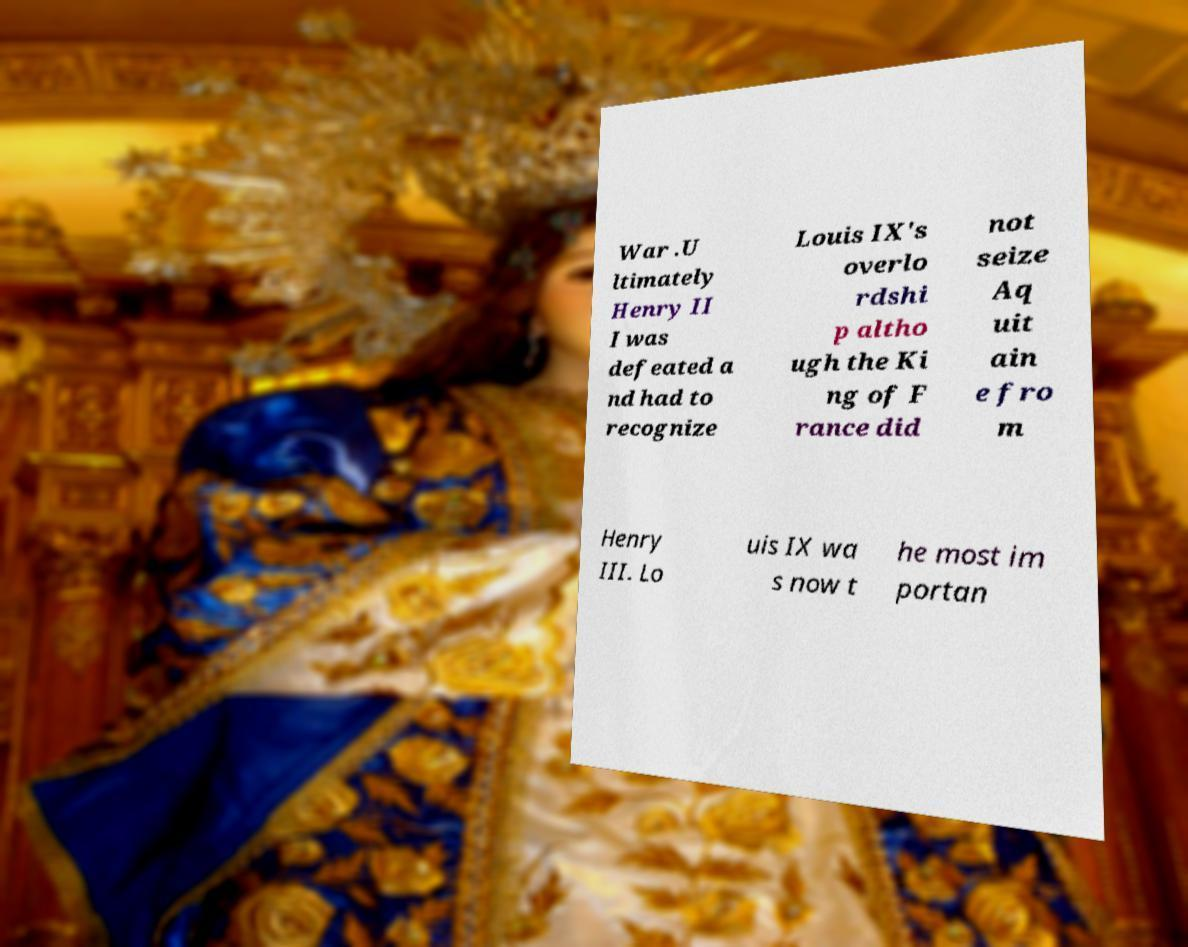Please read and relay the text visible in this image. What does it say? War .U ltimately Henry II I was defeated a nd had to recognize Louis IX's overlo rdshi p altho ugh the Ki ng of F rance did not seize Aq uit ain e fro m Henry III. Lo uis IX wa s now t he most im portan 